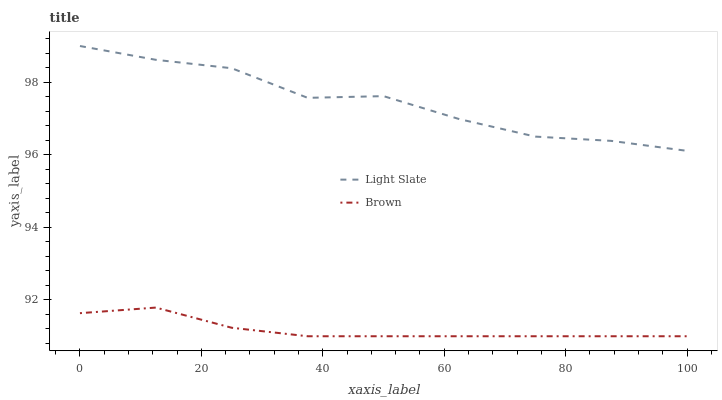Does Brown have the minimum area under the curve?
Answer yes or no. Yes. Does Light Slate have the maximum area under the curve?
Answer yes or no. Yes. Does Brown have the maximum area under the curve?
Answer yes or no. No. Is Brown the smoothest?
Answer yes or no. Yes. Is Light Slate the roughest?
Answer yes or no. Yes. Is Brown the roughest?
Answer yes or no. No. Does Brown have the lowest value?
Answer yes or no. Yes. Does Light Slate have the highest value?
Answer yes or no. Yes. Does Brown have the highest value?
Answer yes or no. No. Is Brown less than Light Slate?
Answer yes or no. Yes. Is Light Slate greater than Brown?
Answer yes or no. Yes. Does Brown intersect Light Slate?
Answer yes or no. No. 